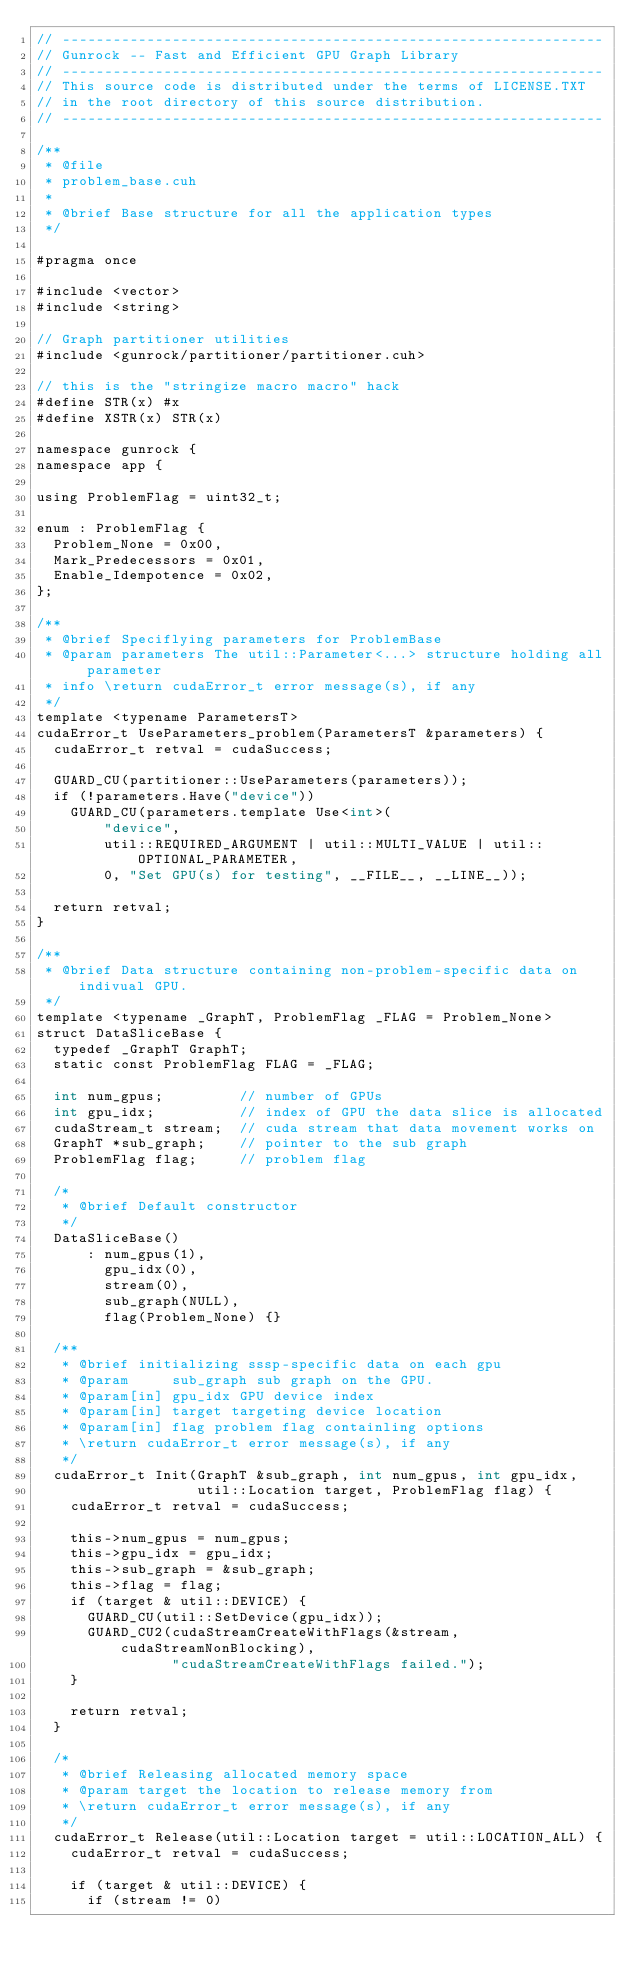Convert code to text. <code><loc_0><loc_0><loc_500><loc_500><_Cuda_>// ----------------------------------------------------------------
// Gunrock -- Fast and Efficient GPU Graph Library
// ----------------------------------------------------------------
// This source code is distributed under the terms of LICENSE.TXT
// in the root directory of this source distribution.
// ----------------------------------------------------------------

/**
 * @file
 * problem_base.cuh
 *
 * @brief Base structure for all the application types
 */

#pragma once

#include <vector>
#include <string>

// Graph partitioner utilities
#include <gunrock/partitioner/partitioner.cuh>

// this is the "stringize macro macro" hack
#define STR(x) #x
#define XSTR(x) STR(x)

namespace gunrock {
namespace app {

using ProblemFlag = uint32_t;

enum : ProblemFlag {
  Problem_None = 0x00,
  Mark_Predecessors = 0x01,
  Enable_Idempotence = 0x02,
};

/**
 * @brief Speciflying parameters for ProblemBase
 * @param parameters The util::Parameter<...> structure holding all parameter
 * info \return cudaError_t error message(s), if any
 */
template <typename ParametersT>
cudaError_t UseParameters_problem(ParametersT &parameters) {
  cudaError_t retval = cudaSuccess;

  GUARD_CU(partitioner::UseParameters(parameters));
  if (!parameters.Have("device"))
    GUARD_CU(parameters.template Use<int>(
        "device",
        util::REQUIRED_ARGUMENT | util::MULTI_VALUE | util::OPTIONAL_PARAMETER,
        0, "Set GPU(s) for testing", __FILE__, __LINE__));

  return retval;
}

/**
 * @brief Data structure containing non-problem-specific data on indivual GPU.
 */
template <typename _GraphT, ProblemFlag _FLAG = Problem_None>
struct DataSliceBase {
  typedef _GraphT GraphT;
  static const ProblemFlag FLAG = _FLAG;

  int num_gpus;         // number of GPUs
  int gpu_idx;          // index of GPU the data slice is allocated
  cudaStream_t stream;  // cuda stream that data movement works on
  GraphT *sub_graph;    // pointer to the sub graph
  ProblemFlag flag;     // problem flag

  /*
   * @brief Default constructor
   */
  DataSliceBase()
      : num_gpus(1),
        gpu_idx(0),
        stream(0),
        sub_graph(NULL),
        flag(Problem_None) {}

  /**
   * @brief initializing sssp-specific data on each gpu
   * @param     sub_graph sub graph on the GPU.
   * @param[in] gpu_idx GPU device index
   * @param[in] target targeting device location
   * @param[in] flag problem flag containling options
   * \return cudaError_t error message(s), if any
   */
  cudaError_t Init(GraphT &sub_graph, int num_gpus, int gpu_idx,
                   util::Location target, ProblemFlag flag) {
    cudaError_t retval = cudaSuccess;

    this->num_gpus = num_gpus;
    this->gpu_idx = gpu_idx;
    this->sub_graph = &sub_graph;
    this->flag = flag;
    if (target & util::DEVICE) {
      GUARD_CU(util::SetDevice(gpu_idx));
      GUARD_CU2(cudaStreamCreateWithFlags(&stream, cudaStreamNonBlocking),
                "cudaStreamCreateWithFlags failed.");
    }

    return retval;
  }

  /*
   * @brief Releasing allocated memory space
   * @param target the location to release memory from
   * \return cudaError_t error message(s), if any
   */
  cudaError_t Release(util::Location target = util::LOCATION_ALL) {
    cudaError_t retval = cudaSuccess;

    if (target & util::DEVICE) {
      if (stream != 0)</code> 